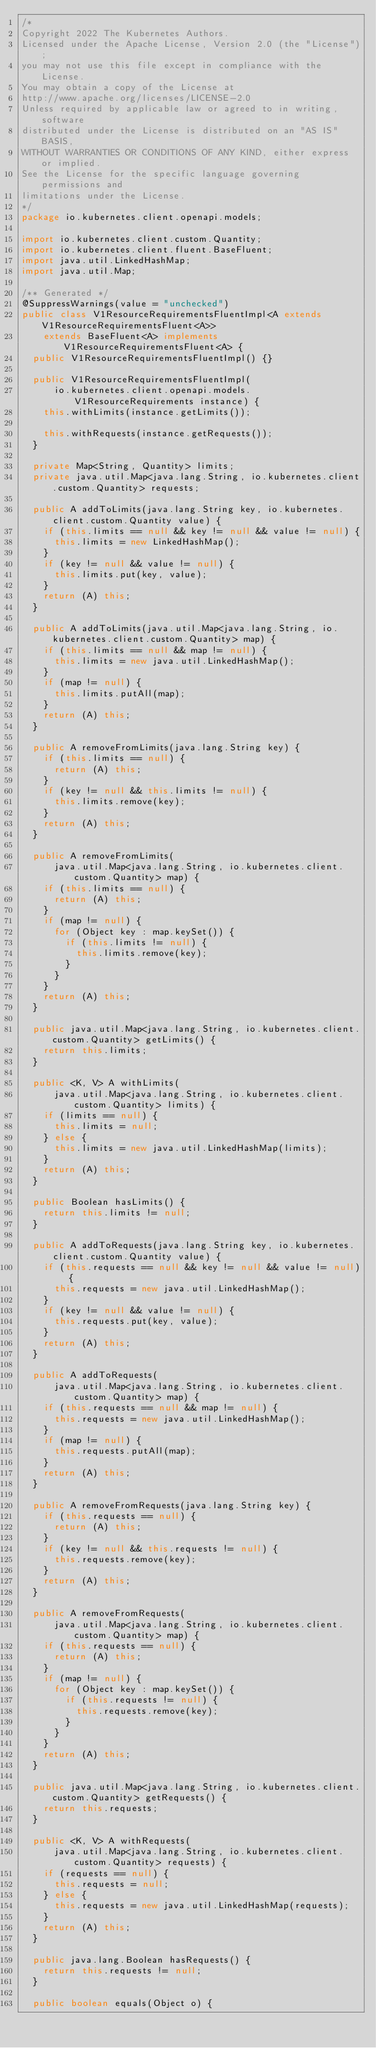<code> <loc_0><loc_0><loc_500><loc_500><_Java_>/*
Copyright 2022 The Kubernetes Authors.
Licensed under the Apache License, Version 2.0 (the "License");
you may not use this file except in compliance with the License.
You may obtain a copy of the License at
http://www.apache.org/licenses/LICENSE-2.0
Unless required by applicable law or agreed to in writing, software
distributed under the License is distributed on an "AS IS" BASIS,
WITHOUT WARRANTIES OR CONDITIONS OF ANY KIND, either express or implied.
See the License for the specific language governing permissions and
limitations under the License.
*/
package io.kubernetes.client.openapi.models;

import io.kubernetes.client.custom.Quantity;
import io.kubernetes.client.fluent.BaseFluent;
import java.util.LinkedHashMap;
import java.util.Map;

/** Generated */
@SuppressWarnings(value = "unchecked")
public class V1ResourceRequirementsFluentImpl<A extends V1ResourceRequirementsFluent<A>>
    extends BaseFluent<A> implements V1ResourceRequirementsFluent<A> {
  public V1ResourceRequirementsFluentImpl() {}

  public V1ResourceRequirementsFluentImpl(
      io.kubernetes.client.openapi.models.V1ResourceRequirements instance) {
    this.withLimits(instance.getLimits());

    this.withRequests(instance.getRequests());
  }

  private Map<String, Quantity> limits;
  private java.util.Map<java.lang.String, io.kubernetes.client.custom.Quantity> requests;

  public A addToLimits(java.lang.String key, io.kubernetes.client.custom.Quantity value) {
    if (this.limits == null && key != null && value != null) {
      this.limits = new LinkedHashMap();
    }
    if (key != null && value != null) {
      this.limits.put(key, value);
    }
    return (A) this;
  }

  public A addToLimits(java.util.Map<java.lang.String, io.kubernetes.client.custom.Quantity> map) {
    if (this.limits == null && map != null) {
      this.limits = new java.util.LinkedHashMap();
    }
    if (map != null) {
      this.limits.putAll(map);
    }
    return (A) this;
  }

  public A removeFromLimits(java.lang.String key) {
    if (this.limits == null) {
      return (A) this;
    }
    if (key != null && this.limits != null) {
      this.limits.remove(key);
    }
    return (A) this;
  }

  public A removeFromLimits(
      java.util.Map<java.lang.String, io.kubernetes.client.custom.Quantity> map) {
    if (this.limits == null) {
      return (A) this;
    }
    if (map != null) {
      for (Object key : map.keySet()) {
        if (this.limits != null) {
          this.limits.remove(key);
        }
      }
    }
    return (A) this;
  }

  public java.util.Map<java.lang.String, io.kubernetes.client.custom.Quantity> getLimits() {
    return this.limits;
  }

  public <K, V> A withLimits(
      java.util.Map<java.lang.String, io.kubernetes.client.custom.Quantity> limits) {
    if (limits == null) {
      this.limits = null;
    } else {
      this.limits = new java.util.LinkedHashMap(limits);
    }
    return (A) this;
  }

  public Boolean hasLimits() {
    return this.limits != null;
  }

  public A addToRequests(java.lang.String key, io.kubernetes.client.custom.Quantity value) {
    if (this.requests == null && key != null && value != null) {
      this.requests = new java.util.LinkedHashMap();
    }
    if (key != null && value != null) {
      this.requests.put(key, value);
    }
    return (A) this;
  }

  public A addToRequests(
      java.util.Map<java.lang.String, io.kubernetes.client.custom.Quantity> map) {
    if (this.requests == null && map != null) {
      this.requests = new java.util.LinkedHashMap();
    }
    if (map != null) {
      this.requests.putAll(map);
    }
    return (A) this;
  }

  public A removeFromRequests(java.lang.String key) {
    if (this.requests == null) {
      return (A) this;
    }
    if (key != null && this.requests != null) {
      this.requests.remove(key);
    }
    return (A) this;
  }

  public A removeFromRequests(
      java.util.Map<java.lang.String, io.kubernetes.client.custom.Quantity> map) {
    if (this.requests == null) {
      return (A) this;
    }
    if (map != null) {
      for (Object key : map.keySet()) {
        if (this.requests != null) {
          this.requests.remove(key);
        }
      }
    }
    return (A) this;
  }

  public java.util.Map<java.lang.String, io.kubernetes.client.custom.Quantity> getRequests() {
    return this.requests;
  }

  public <K, V> A withRequests(
      java.util.Map<java.lang.String, io.kubernetes.client.custom.Quantity> requests) {
    if (requests == null) {
      this.requests = null;
    } else {
      this.requests = new java.util.LinkedHashMap(requests);
    }
    return (A) this;
  }

  public java.lang.Boolean hasRequests() {
    return this.requests != null;
  }

  public boolean equals(Object o) {</code> 